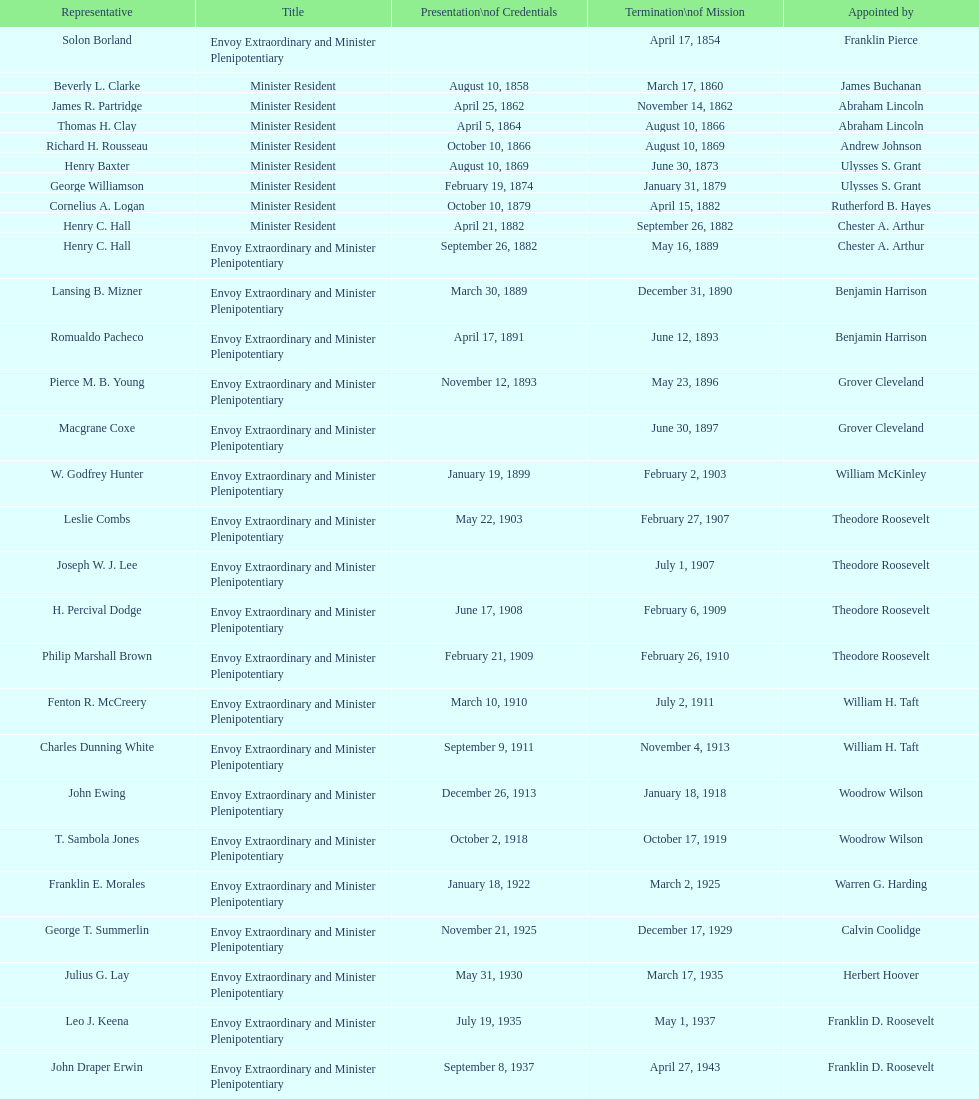Who is the sole ambassador appointed by barack obama to represent the us in honduras? Lisa Kubiske. 